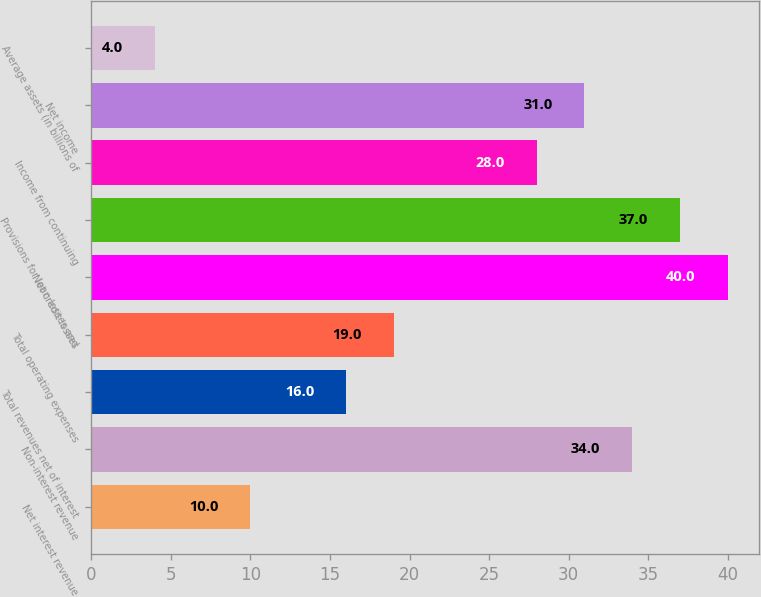Convert chart. <chart><loc_0><loc_0><loc_500><loc_500><bar_chart><fcel>Net interest revenue<fcel>Non-interest revenue<fcel>Total revenues net of interest<fcel>Total operating expenses<fcel>Net credit losses<fcel>Provisions for loan losses and<fcel>Income from continuing<fcel>Net income<fcel>Average assets (in billions of<nl><fcel>10<fcel>34<fcel>16<fcel>19<fcel>40<fcel>37<fcel>28<fcel>31<fcel>4<nl></chart> 